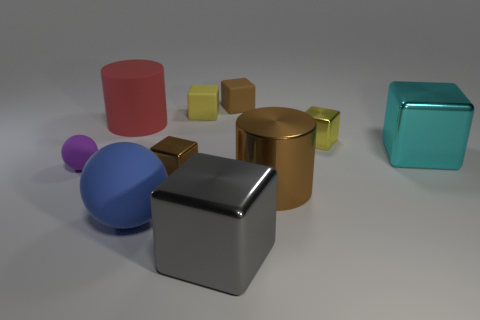What size is the red thing that is the same material as the purple ball?
Ensure brevity in your answer.  Large. What shape is the metal thing that is the same color as the big shiny cylinder?
Provide a short and direct response. Cube. What shape is the small brown thing that is made of the same material as the cyan thing?
Your answer should be compact. Cube. Is the shape of the large gray metallic thing the same as the brown matte object?
Provide a short and direct response. Yes. The small matte ball has what color?
Ensure brevity in your answer.  Purple. What number of things are either brown metal objects or red matte cylinders?
Provide a succinct answer. 3. Are there fewer objects to the left of the large gray metallic block than large yellow cubes?
Keep it short and to the point. No. Is the number of brown metal cylinders that are behind the gray shiny object greater than the number of yellow rubber blocks that are on the left side of the large rubber sphere?
Provide a short and direct response. Yes. Are there any other things that are the same color as the big shiny cylinder?
Provide a succinct answer. Yes. There is a red object that is behind the cyan shiny object; what is its material?
Give a very brief answer. Rubber. 